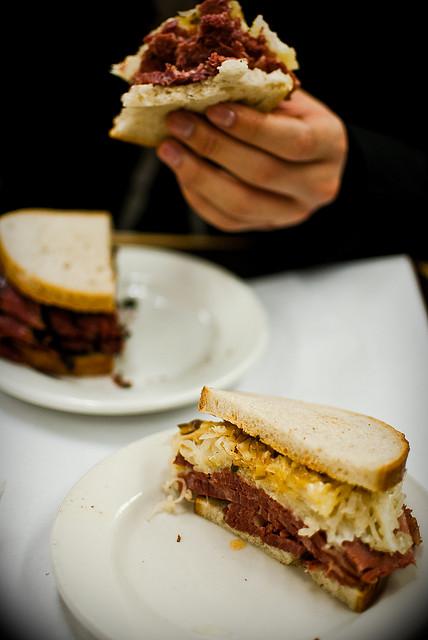How many digits are making contact with the food item?
Write a very short answer. 5. Are there seeds on the bread?
Write a very short answer. No. What meal is this likely to be?
Give a very brief answer. Lunch. Do these sandwiches look tasty?
Be succinct. Yes. Are there pastries in this image?
Be succinct. No. What is the food?
Keep it brief. Sandwich. Is this a healthy meal?
Short answer required. No. Is this going to be used for another meal?
Write a very short answer. No. Is this a fancy or plain meal?
Give a very brief answer. Plain. Is this a sandwich?
Be succinct. Yes. Is that a folk the person is holding?
Keep it brief. No. Who will eat the other sandwiches seen?
Answer briefly. Person. What is on the plate?
Answer briefly. Sandwich. What is the man doing to his sandwich?
Short answer required. Eating. 